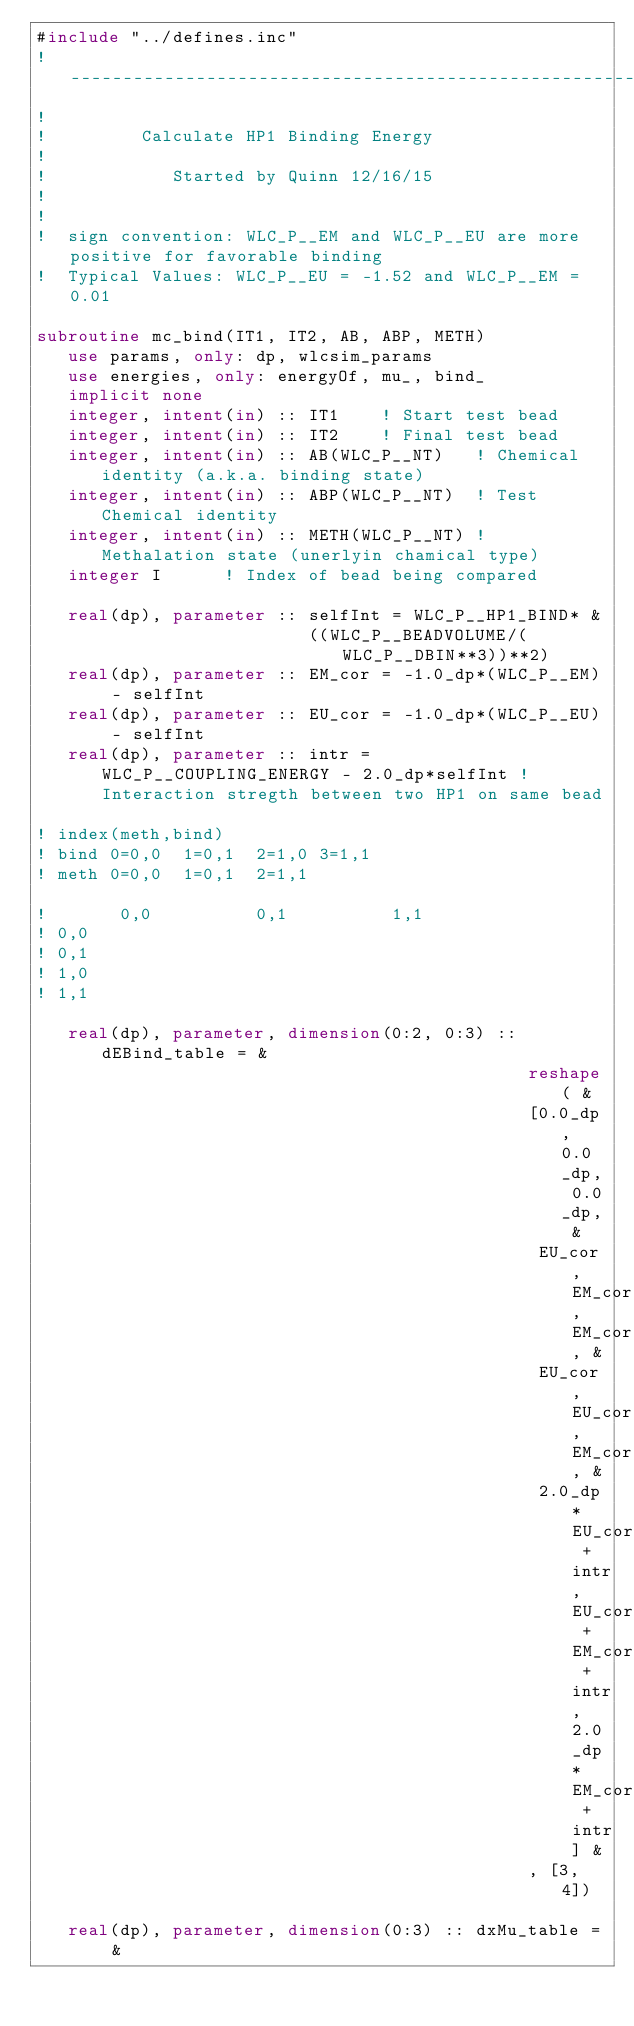Convert code to text. <code><loc_0><loc_0><loc_500><loc_500><_FORTRAN_>#include "../defines.inc"
!-----------------------------------------------------------!
!
!         Calculate HP1 Binding Energy
!
!            Started by Quinn 12/16/15
!
!
!  sign convention: WLC_P__EM and WLC_P__EU are more positive for favorable binding
!  Typical Values: WLC_P__EU = -1.52 and WLC_P__EM = 0.01

subroutine mc_bind(IT1, IT2, AB, ABP, METH)
   use params, only: dp, wlcsim_params
   use energies, only: energyOf, mu_, bind_
   implicit none
   integer, intent(in) :: IT1    ! Start test bead
   integer, intent(in) :: IT2    ! Final test bead
   integer, intent(in) :: AB(WLC_P__NT)   ! Chemical identity (a.k.a. binding state)
   integer, intent(in) :: ABP(WLC_P__NT)  ! Test Chemical identity
   integer, intent(in) :: METH(WLC_P__NT) ! Methalation state (unerlyin chamical type)
   integer I      ! Index of bead being compared

   real(dp), parameter :: selfInt = WLC_P__HP1_BIND* &
                          ((WLC_P__BEADVOLUME/(WLC_P__DBIN**3))**2)
   real(dp), parameter :: EM_cor = -1.0_dp*(WLC_P__EM) - selfInt
   real(dp), parameter :: EU_cor = -1.0_dp*(WLC_P__EU) - selfInt
   real(dp), parameter :: intr = WLC_P__COUPLING_ENERGY - 2.0_dp*selfInt ! Interaction stregth between two HP1 on same bead

! index(meth,bind)
! bind 0=0,0  1=0,1  2=1,0 3=1,1
! meth 0=0,0  1=0,1  2=1,1

!       0,0          0,1          1,1
! 0,0
! 0,1
! 1,0
! 1,1

   real(dp), parameter, dimension(0:2, 0:3) :: dEBind_table = &
                                               reshape( &
                                               [0.0_dp, 0.0_dp, 0.0_dp, &
                                                EU_cor, EM_cor, EM_cor, &
                                                EU_cor, EU_cor, EM_cor, &
                                                2.0_dp*EU_cor + intr, EU_cor + EM_cor + intr, 2.0_dp*EM_cor + intr] &
                                               , [3, 4])

   real(dp), parameter, dimension(0:3) :: dxMu_table = &</code> 